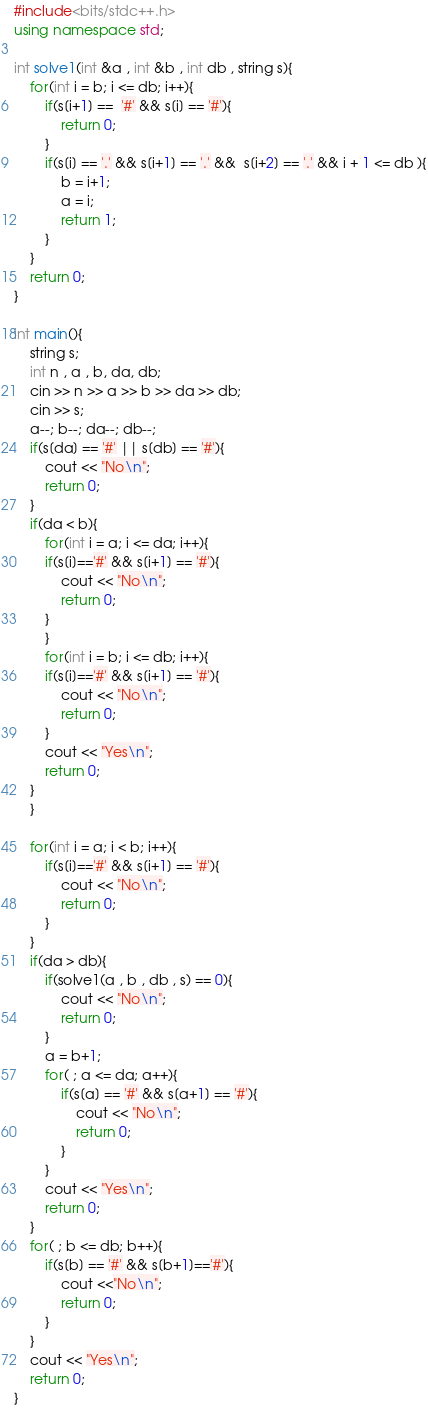Convert code to text. <code><loc_0><loc_0><loc_500><loc_500><_C++_>#include<bits/stdc++.h>
using namespace std;

int solve1(int &a , int &b , int db , string s){
    for(int i = b; i <= db; i++){
        if(s[i+1] ==  '#' && s[i] == '#'){
            return 0;
        }
        if(s[i] == '.' && s[i+1] == '.' &&  s[i+2] == '.' && i + 1 <= db ){
            b = i+1;
            a = i;
            return 1;
        }
    }
    return 0;
}

int main(){
    string s;
    int n , a , b, da, db;
    cin >> n >> a >> b >> da >> db;
    cin >> s;
    a--; b--; da--; db--;
    if(s[da] == '#' || s[db] == '#'){
        cout << "No\n";
        return 0;
    }
    if(da < b){
        for(int i = a; i <= da; i++){
        if(s[i]=='#' && s[i+1] == '#'){
            cout << "No\n";
            return 0;
        }
        }
        for(int i = b; i <= db; i++){
        if(s[i]=='#' && s[i+1] == '#'){
            cout << "No\n";
            return 0;
        }
        cout << "Yes\n";
        return 0;
    }
    }
    
    for(int i = a; i < b; i++){
        if(s[i]=='#' && s[i+1] == '#'){
            cout << "No\n";
            return 0;
        }
    }
    if(da > db){
        if(solve1(a , b , db , s) == 0){
            cout << "No\n";
            return 0;
        }
        a = b+1;
        for( ; a <= da; a++){
            if(s[a] == '#' && s[a+1] == '#'){
                cout << "No\n";
                return 0;
            }
        }
        cout << "Yes\n";
        return 0;
    }
    for( ; b <= db; b++){
        if(s[b] == '#' && s[b+1]=='#'){
            cout <<"No\n";
            return 0;
        }
    }
    cout << "Yes\n";
    return 0;
}</code> 